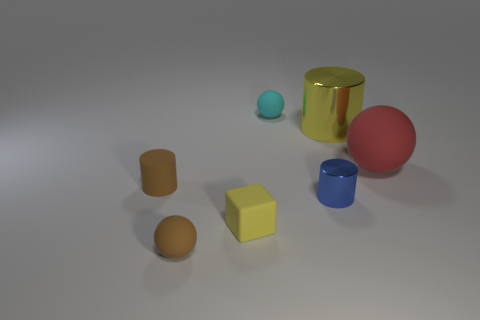Are there any tiny gray rubber things?
Your response must be concise. No. There is a cylinder that is to the right of the tiny cyan sphere and in front of the big rubber ball; what size is it?
Provide a succinct answer. Small. Is the number of objects that are behind the yellow matte block greater than the number of large red rubber objects to the left of the small blue cylinder?
Provide a succinct answer. Yes. There is another object that is the same color as the big shiny thing; what is its size?
Make the answer very short. Small. The block is what color?
Give a very brief answer. Yellow. The cylinder that is both behind the tiny blue thing and right of the yellow cube is what color?
Provide a succinct answer. Yellow. What is the color of the tiny cylinder to the right of the brown rubber thing behind the small brown matte thing that is in front of the blue cylinder?
Give a very brief answer. Blue. What is the color of the metal cylinder that is the same size as the yellow rubber object?
Offer a very short reply. Blue. What shape is the brown rubber thing in front of the tiny matte object that is on the left side of the brown rubber object that is in front of the yellow rubber block?
Give a very brief answer. Sphere. What shape is the big shiny thing that is the same color as the matte cube?
Keep it short and to the point. Cylinder. 